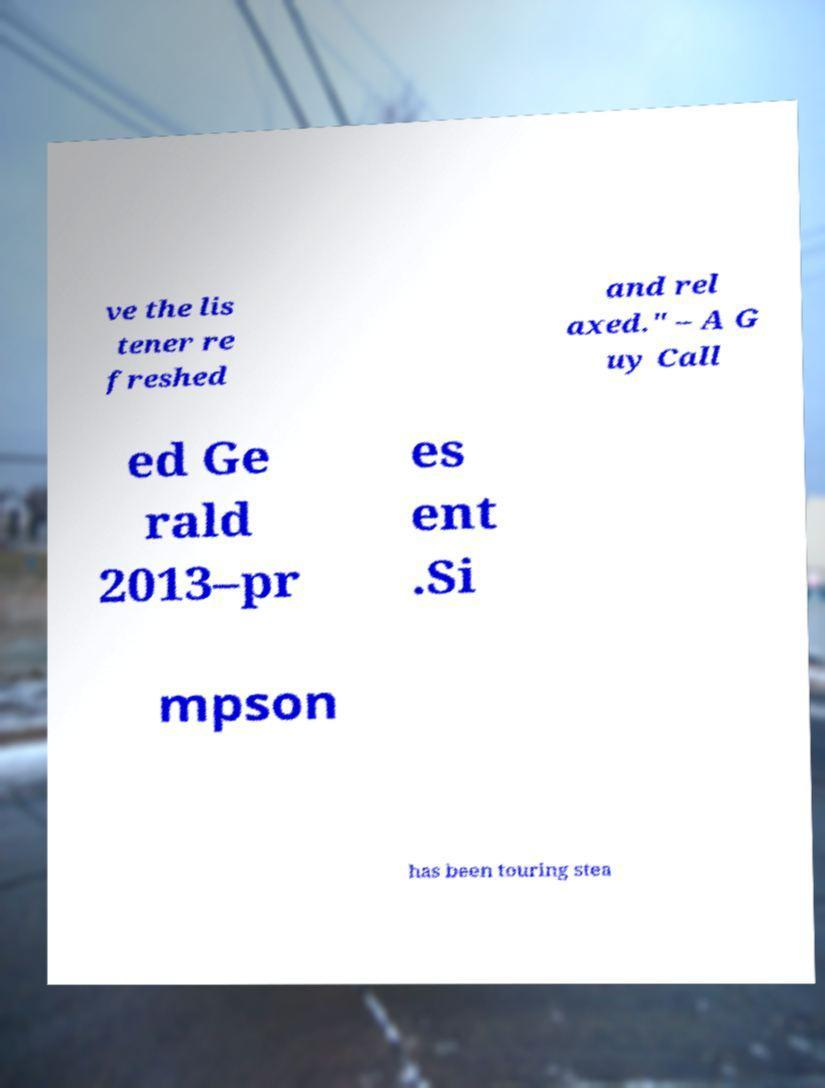For documentation purposes, I need the text within this image transcribed. Could you provide that? ve the lis tener re freshed and rel axed." – A G uy Call ed Ge rald 2013–pr es ent .Si mpson has been touring stea 